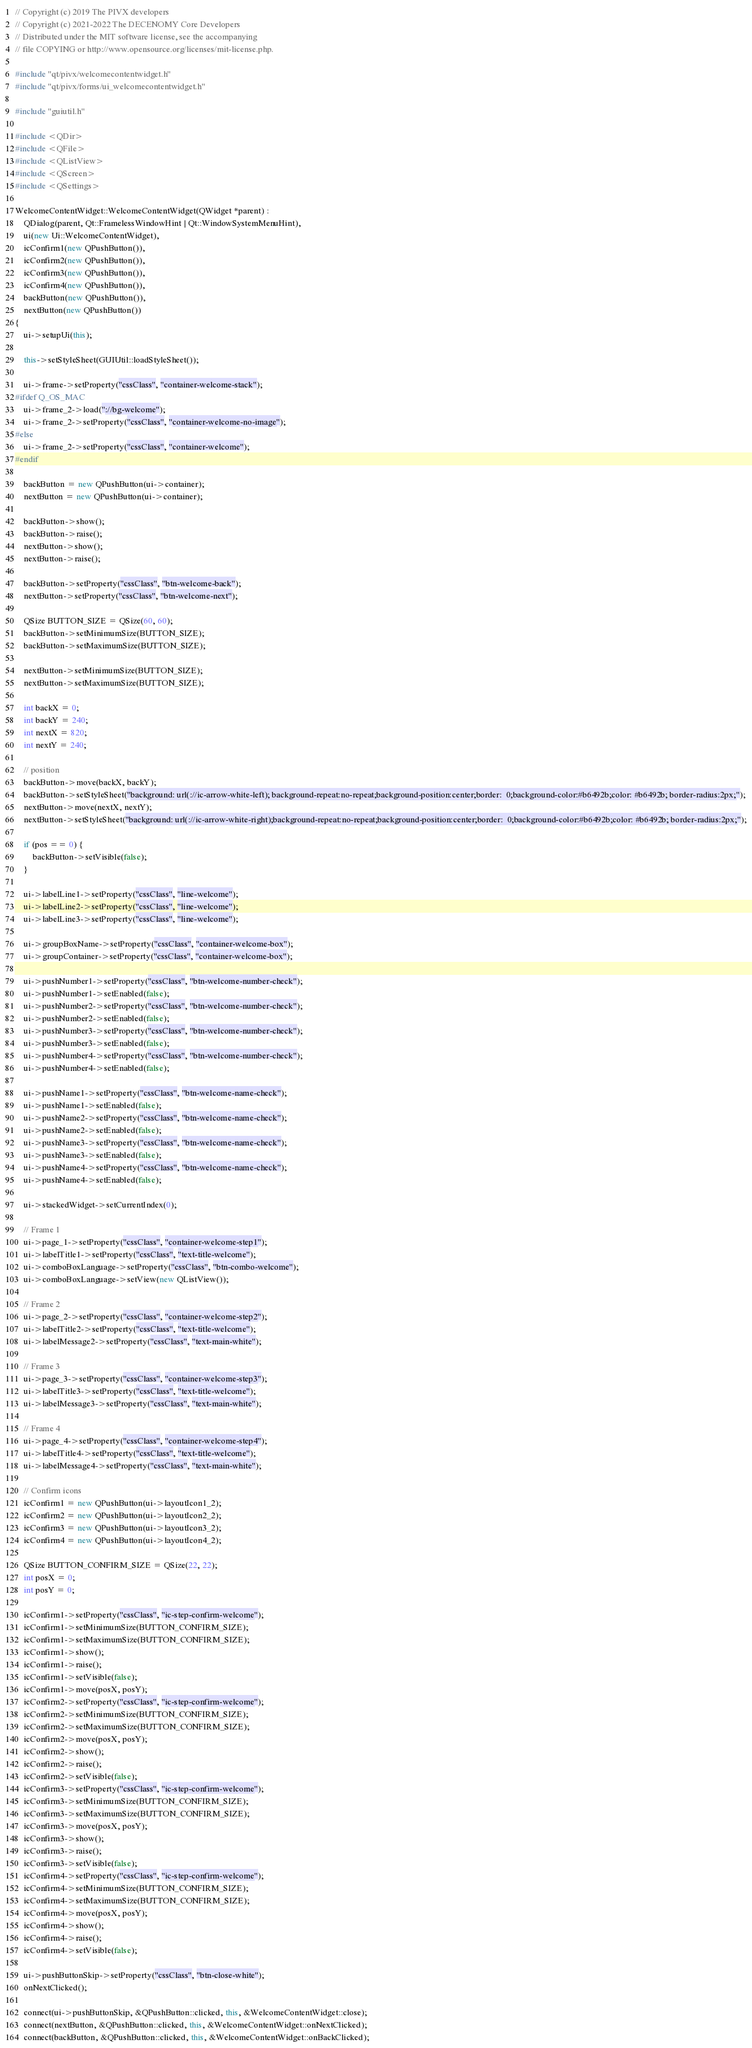<code> <loc_0><loc_0><loc_500><loc_500><_C++_>// Copyright (c) 2019 The PIVX developers
// Copyright (c) 2021-2022 The DECENOMY Core Developers
// Distributed under the MIT software license, see the accompanying
// file COPYING or http://www.opensource.org/licenses/mit-license.php.

#include "qt/pivx/welcomecontentwidget.h"
#include "qt/pivx/forms/ui_welcomecontentwidget.h"

#include "guiutil.h"

#include <QDir>
#include <QFile>
#include <QListView>
#include <QScreen>
#include <QSettings>

WelcomeContentWidget::WelcomeContentWidget(QWidget *parent) :
    QDialog(parent, Qt::FramelessWindowHint | Qt::WindowSystemMenuHint),
    ui(new Ui::WelcomeContentWidget),
    icConfirm1(new QPushButton()),
    icConfirm2(new QPushButton()),
    icConfirm3(new QPushButton()),
    icConfirm4(new QPushButton()),
    backButton(new QPushButton()),
    nextButton(new QPushButton())
{
    ui->setupUi(this);

    this->setStyleSheet(GUIUtil::loadStyleSheet());

    ui->frame->setProperty("cssClass", "container-welcome-stack");
#ifdef Q_OS_MAC
    ui->frame_2->load("://bg-welcome");
    ui->frame_2->setProperty("cssClass", "container-welcome-no-image");
#else
    ui->frame_2->setProperty("cssClass", "container-welcome");
#endif

    backButton = new QPushButton(ui->container);
    nextButton = new QPushButton(ui->container);

    backButton->show();
    backButton->raise();
    nextButton->show();
    nextButton->raise();

    backButton->setProperty("cssClass", "btn-welcome-back");
    nextButton->setProperty("cssClass", "btn-welcome-next");

    QSize BUTTON_SIZE = QSize(60, 60);
    backButton->setMinimumSize(BUTTON_SIZE);
    backButton->setMaximumSize(BUTTON_SIZE);

    nextButton->setMinimumSize(BUTTON_SIZE);
    nextButton->setMaximumSize(BUTTON_SIZE);

    int backX = 0;
    int backY = 240;
    int nextX = 820;
    int nextY = 240;

    // position
    backButton->move(backX, backY);
    backButton->setStyleSheet("background: url(://ic-arrow-white-left); background-repeat:no-repeat;background-position:center;border:  0;background-color:#b6492b;color: #b6492b; border-radius:2px;");
    nextButton->move(nextX, nextY);
    nextButton->setStyleSheet("background: url(://ic-arrow-white-right);background-repeat:no-repeat;background-position:center;border:  0;background-color:#b6492b;color: #b6492b; border-radius:2px;");

    if (pos == 0) {
        backButton->setVisible(false);
    }

    ui->labelLine1->setProperty("cssClass", "line-welcome");
    ui->labelLine2->setProperty("cssClass", "line-welcome");
    ui->labelLine3->setProperty("cssClass", "line-welcome");

    ui->groupBoxName->setProperty("cssClass", "container-welcome-box");
    ui->groupContainer->setProperty("cssClass", "container-welcome-box");

    ui->pushNumber1->setProperty("cssClass", "btn-welcome-number-check");
    ui->pushNumber1->setEnabled(false);
    ui->pushNumber2->setProperty("cssClass", "btn-welcome-number-check");
    ui->pushNumber2->setEnabled(false);
    ui->pushNumber3->setProperty("cssClass", "btn-welcome-number-check");
    ui->pushNumber3->setEnabled(false);
    ui->pushNumber4->setProperty("cssClass", "btn-welcome-number-check");
    ui->pushNumber4->setEnabled(false);

    ui->pushName1->setProperty("cssClass", "btn-welcome-name-check");
    ui->pushName1->setEnabled(false);
    ui->pushName2->setProperty("cssClass", "btn-welcome-name-check");
    ui->pushName2->setEnabled(false);
    ui->pushName3->setProperty("cssClass", "btn-welcome-name-check");
    ui->pushName3->setEnabled(false);
    ui->pushName4->setProperty("cssClass", "btn-welcome-name-check");
    ui->pushName4->setEnabled(false);

    ui->stackedWidget->setCurrentIndex(0);

    // Frame 1
    ui->page_1->setProperty("cssClass", "container-welcome-step1");
    ui->labelTitle1->setProperty("cssClass", "text-title-welcome");
    ui->comboBoxLanguage->setProperty("cssClass", "btn-combo-welcome");
    ui->comboBoxLanguage->setView(new QListView());

    // Frame 2
    ui->page_2->setProperty("cssClass", "container-welcome-step2");
    ui->labelTitle2->setProperty("cssClass", "text-title-welcome");
    ui->labelMessage2->setProperty("cssClass", "text-main-white");

    // Frame 3
    ui->page_3->setProperty("cssClass", "container-welcome-step3");
    ui->labelTitle3->setProperty("cssClass", "text-title-welcome");
    ui->labelMessage3->setProperty("cssClass", "text-main-white");

    // Frame 4
    ui->page_4->setProperty("cssClass", "container-welcome-step4");
    ui->labelTitle4->setProperty("cssClass", "text-title-welcome");
    ui->labelMessage4->setProperty("cssClass", "text-main-white");

    // Confirm icons
    icConfirm1 = new QPushButton(ui->layoutIcon1_2);
    icConfirm2 = new QPushButton(ui->layoutIcon2_2);
    icConfirm3 = new QPushButton(ui->layoutIcon3_2);
    icConfirm4 = new QPushButton(ui->layoutIcon4_2);

    QSize BUTTON_CONFIRM_SIZE = QSize(22, 22);
    int posX = 0;
    int posY = 0;

    icConfirm1->setProperty("cssClass", "ic-step-confirm-welcome");
    icConfirm1->setMinimumSize(BUTTON_CONFIRM_SIZE);
    icConfirm1->setMaximumSize(BUTTON_CONFIRM_SIZE);
    icConfirm1->show();
    icConfirm1->raise();
    icConfirm1->setVisible(false);
    icConfirm1->move(posX, posY);
    icConfirm2->setProperty("cssClass", "ic-step-confirm-welcome");
    icConfirm2->setMinimumSize(BUTTON_CONFIRM_SIZE);
    icConfirm2->setMaximumSize(BUTTON_CONFIRM_SIZE);
    icConfirm2->move(posX, posY);
    icConfirm2->show();
    icConfirm2->raise();
    icConfirm2->setVisible(false);
    icConfirm3->setProperty("cssClass", "ic-step-confirm-welcome");
    icConfirm3->setMinimumSize(BUTTON_CONFIRM_SIZE);
    icConfirm3->setMaximumSize(BUTTON_CONFIRM_SIZE);
    icConfirm3->move(posX, posY);
    icConfirm3->show();
    icConfirm3->raise();
    icConfirm3->setVisible(false);
    icConfirm4->setProperty("cssClass", "ic-step-confirm-welcome");
    icConfirm4->setMinimumSize(BUTTON_CONFIRM_SIZE);
    icConfirm4->setMaximumSize(BUTTON_CONFIRM_SIZE);
    icConfirm4->move(posX, posY);
    icConfirm4->show();
    icConfirm4->raise();
    icConfirm4->setVisible(false);

    ui->pushButtonSkip->setProperty("cssClass", "btn-close-white");
    onNextClicked();

    connect(ui->pushButtonSkip, &QPushButton::clicked, this, &WelcomeContentWidget::close);
    connect(nextButton, &QPushButton::clicked, this, &WelcomeContentWidget::onNextClicked);
    connect(backButton, &QPushButton::clicked, this, &WelcomeContentWidget::onBackClicked);</code> 